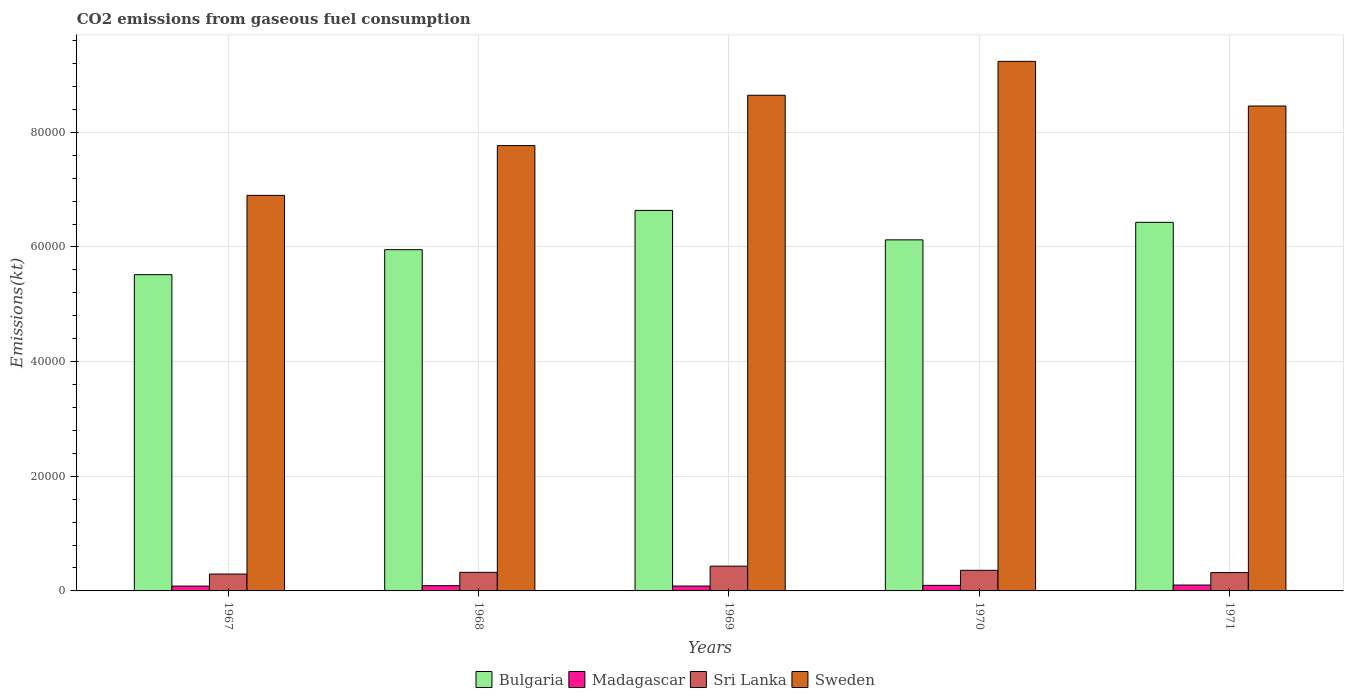How many groups of bars are there?
Provide a succinct answer. 5. Are the number of bars per tick equal to the number of legend labels?
Make the answer very short. Yes. Are the number of bars on each tick of the X-axis equal?
Keep it short and to the point. Yes. How many bars are there on the 1st tick from the right?
Keep it short and to the point. 4. What is the label of the 1st group of bars from the left?
Ensure brevity in your answer.  1967. What is the amount of CO2 emitted in Sri Lanka in 1968?
Offer a very short reply. 3241.63. Across all years, what is the maximum amount of CO2 emitted in Bulgaria?
Give a very brief answer. 6.64e+04. Across all years, what is the minimum amount of CO2 emitted in Bulgaria?
Keep it short and to the point. 5.52e+04. In which year was the amount of CO2 emitted in Sri Lanka minimum?
Provide a short and direct response. 1967. What is the total amount of CO2 emitted in Sri Lanka in the graph?
Provide a short and direct response. 1.73e+04. What is the difference between the amount of CO2 emitted in Sweden in 1967 and that in 1968?
Your answer should be compact. -8683.46. What is the difference between the amount of CO2 emitted in Sweden in 1969 and the amount of CO2 emitted in Madagascar in 1970?
Your answer should be compact. 8.55e+04. What is the average amount of CO2 emitted in Sweden per year?
Offer a very short reply. 8.20e+04. In the year 1971, what is the difference between the amount of CO2 emitted in Madagascar and amount of CO2 emitted in Sweden?
Ensure brevity in your answer.  -8.36e+04. In how many years, is the amount of CO2 emitted in Madagascar greater than 68000 kt?
Keep it short and to the point. 0. What is the ratio of the amount of CO2 emitted in Bulgaria in 1967 to that in 1968?
Make the answer very short. 0.93. Is the amount of CO2 emitted in Bulgaria in 1967 less than that in 1970?
Give a very brief answer. Yes. Is the difference between the amount of CO2 emitted in Madagascar in 1969 and 1971 greater than the difference between the amount of CO2 emitted in Sweden in 1969 and 1971?
Your answer should be very brief. No. What is the difference between the highest and the second highest amount of CO2 emitted in Madagascar?
Give a very brief answer. 55. What is the difference between the highest and the lowest amount of CO2 emitted in Sri Lanka?
Ensure brevity in your answer.  1371.46. In how many years, is the amount of CO2 emitted in Sri Lanka greater than the average amount of CO2 emitted in Sri Lanka taken over all years?
Give a very brief answer. 2. Is the sum of the amount of CO2 emitted in Bulgaria in 1969 and 1970 greater than the maximum amount of CO2 emitted in Sweden across all years?
Provide a succinct answer. Yes. What does the 1st bar from the left in 1968 represents?
Your answer should be very brief. Bulgaria. What does the 2nd bar from the right in 1969 represents?
Offer a very short reply. Sri Lanka. Is it the case that in every year, the sum of the amount of CO2 emitted in Sweden and amount of CO2 emitted in Bulgaria is greater than the amount of CO2 emitted in Madagascar?
Provide a succinct answer. Yes. How many bars are there?
Offer a terse response. 20. Are all the bars in the graph horizontal?
Keep it short and to the point. No. What is the difference between two consecutive major ticks on the Y-axis?
Offer a very short reply. 2.00e+04. Does the graph contain any zero values?
Your response must be concise. No. Does the graph contain grids?
Make the answer very short. Yes. Where does the legend appear in the graph?
Your answer should be compact. Bottom center. What is the title of the graph?
Your answer should be compact. CO2 emissions from gaseous fuel consumption. Does "Denmark" appear as one of the legend labels in the graph?
Offer a very short reply. No. What is the label or title of the Y-axis?
Provide a short and direct response. Emissions(kt). What is the Emissions(kt) in Bulgaria in 1967?
Offer a very short reply. 5.52e+04. What is the Emissions(kt) in Madagascar in 1967?
Ensure brevity in your answer.  843.41. What is the Emissions(kt) in Sri Lanka in 1967?
Offer a very short reply. 2948.27. What is the Emissions(kt) of Sweden in 1967?
Offer a terse response. 6.90e+04. What is the Emissions(kt) in Bulgaria in 1968?
Ensure brevity in your answer.  5.95e+04. What is the Emissions(kt) in Madagascar in 1968?
Your answer should be compact. 913.08. What is the Emissions(kt) in Sri Lanka in 1968?
Offer a terse response. 3241.63. What is the Emissions(kt) in Sweden in 1968?
Provide a short and direct response. 7.77e+04. What is the Emissions(kt) of Bulgaria in 1969?
Your answer should be very brief. 6.64e+04. What is the Emissions(kt) in Madagascar in 1969?
Offer a terse response. 850.74. What is the Emissions(kt) of Sri Lanka in 1969?
Offer a very short reply. 4319.73. What is the Emissions(kt) of Sweden in 1969?
Offer a terse response. 8.65e+04. What is the Emissions(kt) in Bulgaria in 1970?
Offer a very short reply. 6.12e+04. What is the Emissions(kt) in Madagascar in 1970?
Your response must be concise. 971.75. What is the Emissions(kt) of Sri Lanka in 1970?
Your response must be concise. 3597.33. What is the Emissions(kt) of Sweden in 1970?
Offer a terse response. 9.24e+04. What is the Emissions(kt) in Bulgaria in 1971?
Give a very brief answer. 6.43e+04. What is the Emissions(kt) in Madagascar in 1971?
Provide a succinct answer. 1026.76. What is the Emissions(kt) of Sri Lanka in 1971?
Offer a terse response. 3197.62. What is the Emissions(kt) of Sweden in 1971?
Offer a terse response. 8.46e+04. Across all years, what is the maximum Emissions(kt) of Bulgaria?
Provide a short and direct response. 6.64e+04. Across all years, what is the maximum Emissions(kt) of Madagascar?
Your answer should be very brief. 1026.76. Across all years, what is the maximum Emissions(kt) in Sri Lanka?
Offer a terse response. 4319.73. Across all years, what is the maximum Emissions(kt) in Sweden?
Offer a terse response. 9.24e+04. Across all years, what is the minimum Emissions(kt) of Bulgaria?
Your answer should be compact. 5.52e+04. Across all years, what is the minimum Emissions(kt) in Madagascar?
Ensure brevity in your answer.  843.41. Across all years, what is the minimum Emissions(kt) in Sri Lanka?
Ensure brevity in your answer.  2948.27. Across all years, what is the minimum Emissions(kt) of Sweden?
Your response must be concise. 6.90e+04. What is the total Emissions(kt) in Bulgaria in the graph?
Give a very brief answer. 3.07e+05. What is the total Emissions(kt) in Madagascar in the graph?
Provide a short and direct response. 4605.75. What is the total Emissions(kt) in Sri Lanka in the graph?
Provide a succinct answer. 1.73e+04. What is the total Emissions(kt) of Sweden in the graph?
Offer a very short reply. 4.10e+05. What is the difference between the Emissions(kt) in Bulgaria in 1967 and that in 1968?
Offer a terse response. -4360.06. What is the difference between the Emissions(kt) of Madagascar in 1967 and that in 1968?
Make the answer very short. -69.67. What is the difference between the Emissions(kt) of Sri Lanka in 1967 and that in 1968?
Keep it short and to the point. -293.36. What is the difference between the Emissions(kt) in Sweden in 1967 and that in 1968?
Your response must be concise. -8683.46. What is the difference between the Emissions(kt) of Bulgaria in 1967 and that in 1969?
Make the answer very short. -1.12e+04. What is the difference between the Emissions(kt) in Madagascar in 1967 and that in 1969?
Provide a succinct answer. -7.33. What is the difference between the Emissions(kt) of Sri Lanka in 1967 and that in 1969?
Provide a short and direct response. -1371.46. What is the difference between the Emissions(kt) of Sweden in 1967 and that in 1969?
Give a very brief answer. -1.75e+04. What is the difference between the Emissions(kt) of Bulgaria in 1967 and that in 1970?
Offer a terse response. -6072.55. What is the difference between the Emissions(kt) in Madagascar in 1967 and that in 1970?
Make the answer very short. -128.34. What is the difference between the Emissions(kt) of Sri Lanka in 1967 and that in 1970?
Give a very brief answer. -649.06. What is the difference between the Emissions(kt) in Sweden in 1967 and that in 1970?
Provide a succinct answer. -2.34e+04. What is the difference between the Emissions(kt) of Bulgaria in 1967 and that in 1971?
Ensure brevity in your answer.  -9134.5. What is the difference between the Emissions(kt) of Madagascar in 1967 and that in 1971?
Provide a short and direct response. -183.35. What is the difference between the Emissions(kt) in Sri Lanka in 1967 and that in 1971?
Ensure brevity in your answer.  -249.36. What is the difference between the Emissions(kt) of Sweden in 1967 and that in 1971?
Provide a short and direct response. -1.56e+04. What is the difference between the Emissions(kt) in Bulgaria in 1968 and that in 1969?
Provide a short and direct response. -6849.96. What is the difference between the Emissions(kt) in Madagascar in 1968 and that in 1969?
Offer a very short reply. 62.34. What is the difference between the Emissions(kt) of Sri Lanka in 1968 and that in 1969?
Provide a short and direct response. -1078.1. What is the difference between the Emissions(kt) in Sweden in 1968 and that in 1969?
Ensure brevity in your answer.  -8782.47. What is the difference between the Emissions(kt) in Bulgaria in 1968 and that in 1970?
Your answer should be very brief. -1712.49. What is the difference between the Emissions(kt) in Madagascar in 1968 and that in 1970?
Make the answer very short. -58.67. What is the difference between the Emissions(kt) of Sri Lanka in 1968 and that in 1970?
Offer a terse response. -355.7. What is the difference between the Emissions(kt) of Sweden in 1968 and that in 1970?
Offer a terse response. -1.47e+04. What is the difference between the Emissions(kt) of Bulgaria in 1968 and that in 1971?
Ensure brevity in your answer.  -4774.43. What is the difference between the Emissions(kt) of Madagascar in 1968 and that in 1971?
Keep it short and to the point. -113.68. What is the difference between the Emissions(kt) in Sri Lanka in 1968 and that in 1971?
Keep it short and to the point. 44. What is the difference between the Emissions(kt) in Sweden in 1968 and that in 1971?
Give a very brief answer. -6904.96. What is the difference between the Emissions(kt) of Bulgaria in 1969 and that in 1970?
Ensure brevity in your answer.  5137.47. What is the difference between the Emissions(kt) of Madagascar in 1969 and that in 1970?
Provide a short and direct response. -121.01. What is the difference between the Emissions(kt) in Sri Lanka in 1969 and that in 1970?
Your answer should be very brief. 722.4. What is the difference between the Emissions(kt) in Sweden in 1969 and that in 1970?
Make the answer very short. -5911.2. What is the difference between the Emissions(kt) in Bulgaria in 1969 and that in 1971?
Your response must be concise. 2075.52. What is the difference between the Emissions(kt) in Madagascar in 1969 and that in 1971?
Ensure brevity in your answer.  -176.02. What is the difference between the Emissions(kt) in Sri Lanka in 1969 and that in 1971?
Your answer should be compact. 1122.1. What is the difference between the Emissions(kt) in Sweden in 1969 and that in 1971?
Your answer should be compact. 1877.5. What is the difference between the Emissions(kt) in Bulgaria in 1970 and that in 1971?
Your answer should be compact. -3061.95. What is the difference between the Emissions(kt) in Madagascar in 1970 and that in 1971?
Keep it short and to the point. -55.01. What is the difference between the Emissions(kt) of Sri Lanka in 1970 and that in 1971?
Provide a succinct answer. 399.7. What is the difference between the Emissions(kt) in Sweden in 1970 and that in 1971?
Ensure brevity in your answer.  7788.71. What is the difference between the Emissions(kt) of Bulgaria in 1967 and the Emissions(kt) of Madagascar in 1968?
Make the answer very short. 5.43e+04. What is the difference between the Emissions(kt) of Bulgaria in 1967 and the Emissions(kt) of Sri Lanka in 1968?
Your answer should be compact. 5.19e+04. What is the difference between the Emissions(kt) in Bulgaria in 1967 and the Emissions(kt) in Sweden in 1968?
Your answer should be compact. -2.25e+04. What is the difference between the Emissions(kt) of Madagascar in 1967 and the Emissions(kt) of Sri Lanka in 1968?
Your answer should be very brief. -2398.22. What is the difference between the Emissions(kt) in Madagascar in 1967 and the Emissions(kt) in Sweden in 1968?
Provide a succinct answer. -7.68e+04. What is the difference between the Emissions(kt) in Sri Lanka in 1967 and the Emissions(kt) in Sweden in 1968?
Your answer should be very brief. -7.47e+04. What is the difference between the Emissions(kt) of Bulgaria in 1967 and the Emissions(kt) of Madagascar in 1969?
Your response must be concise. 5.43e+04. What is the difference between the Emissions(kt) in Bulgaria in 1967 and the Emissions(kt) in Sri Lanka in 1969?
Give a very brief answer. 5.08e+04. What is the difference between the Emissions(kt) of Bulgaria in 1967 and the Emissions(kt) of Sweden in 1969?
Offer a very short reply. -3.13e+04. What is the difference between the Emissions(kt) in Madagascar in 1967 and the Emissions(kt) in Sri Lanka in 1969?
Make the answer very short. -3476.32. What is the difference between the Emissions(kt) in Madagascar in 1967 and the Emissions(kt) in Sweden in 1969?
Your answer should be very brief. -8.56e+04. What is the difference between the Emissions(kt) in Sri Lanka in 1967 and the Emissions(kt) in Sweden in 1969?
Make the answer very short. -8.35e+04. What is the difference between the Emissions(kt) of Bulgaria in 1967 and the Emissions(kt) of Madagascar in 1970?
Offer a very short reply. 5.42e+04. What is the difference between the Emissions(kt) in Bulgaria in 1967 and the Emissions(kt) in Sri Lanka in 1970?
Your answer should be very brief. 5.16e+04. What is the difference between the Emissions(kt) in Bulgaria in 1967 and the Emissions(kt) in Sweden in 1970?
Ensure brevity in your answer.  -3.72e+04. What is the difference between the Emissions(kt) in Madagascar in 1967 and the Emissions(kt) in Sri Lanka in 1970?
Your response must be concise. -2753.92. What is the difference between the Emissions(kt) in Madagascar in 1967 and the Emissions(kt) in Sweden in 1970?
Ensure brevity in your answer.  -9.15e+04. What is the difference between the Emissions(kt) of Sri Lanka in 1967 and the Emissions(kt) of Sweden in 1970?
Make the answer very short. -8.94e+04. What is the difference between the Emissions(kt) in Bulgaria in 1967 and the Emissions(kt) in Madagascar in 1971?
Your response must be concise. 5.41e+04. What is the difference between the Emissions(kt) of Bulgaria in 1967 and the Emissions(kt) of Sri Lanka in 1971?
Provide a succinct answer. 5.20e+04. What is the difference between the Emissions(kt) of Bulgaria in 1967 and the Emissions(kt) of Sweden in 1971?
Give a very brief answer. -2.94e+04. What is the difference between the Emissions(kt) in Madagascar in 1967 and the Emissions(kt) in Sri Lanka in 1971?
Provide a succinct answer. -2354.21. What is the difference between the Emissions(kt) of Madagascar in 1967 and the Emissions(kt) of Sweden in 1971?
Your answer should be very brief. -8.37e+04. What is the difference between the Emissions(kt) of Sri Lanka in 1967 and the Emissions(kt) of Sweden in 1971?
Keep it short and to the point. -8.16e+04. What is the difference between the Emissions(kt) in Bulgaria in 1968 and the Emissions(kt) in Madagascar in 1969?
Provide a short and direct response. 5.87e+04. What is the difference between the Emissions(kt) in Bulgaria in 1968 and the Emissions(kt) in Sri Lanka in 1969?
Offer a very short reply. 5.52e+04. What is the difference between the Emissions(kt) in Bulgaria in 1968 and the Emissions(kt) in Sweden in 1969?
Offer a very short reply. -2.69e+04. What is the difference between the Emissions(kt) in Madagascar in 1968 and the Emissions(kt) in Sri Lanka in 1969?
Offer a very short reply. -3406.64. What is the difference between the Emissions(kt) in Madagascar in 1968 and the Emissions(kt) in Sweden in 1969?
Keep it short and to the point. -8.56e+04. What is the difference between the Emissions(kt) of Sri Lanka in 1968 and the Emissions(kt) of Sweden in 1969?
Give a very brief answer. -8.32e+04. What is the difference between the Emissions(kt) in Bulgaria in 1968 and the Emissions(kt) in Madagascar in 1970?
Offer a terse response. 5.86e+04. What is the difference between the Emissions(kt) in Bulgaria in 1968 and the Emissions(kt) in Sri Lanka in 1970?
Provide a short and direct response. 5.59e+04. What is the difference between the Emissions(kt) of Bulgaria in 1968 and the Emissions(kt) of Sweden in 1970?
Your answer should be very brief. -3.29e+04. What is the difference between the Emissions(kt) in Madagascar in 1968 and the Emissions(kt) in Sri Lanka in 1970?
Provide a short and direct response. -2684.24. What is the difference between the Emissions(kt) in Madagascar in 1968 and the Emissions(kt) in Sweden in 1970?
Ensure brevity in your answer.  -9.15e+04. What is the difference between the Emissions(kt) in Sri Lanka in 1968 and the Emissions(kt) in Sweden in 1970?
Keep it short and to the point. -8.91e+04. What is the difference between the Emissions(kt) in Bulgaria in 1968 and the Emissions(kt) in Madagascar in 1971?
Your response must be concise. 5.85e+04. What is the difference between the Emissions(kt) of Bulgaria in 1968 and the Emissions(kt) of Sri Lanka in 1971?
Ensure brevity in your answer.  5.63e+04. What is the difference between the Emissions(kt) of Bulgaria in 1968 and the Emissions(kt) of Sweden in 1971?
Make the answer very short. -2.51e+04. What is the difference between the Emissions(kt) of Madagascar in 1968 and the Emissions(kt) of Sri Lanka in 1971?
Your response must be concise. -2284.54. What is the difference between the Emissions(kt) in Madagascar in 1968 and the Emissions(kt) in Sweden in 1971?
Provide a succinct answer. -8.37e+04. What is the difference between the Emissions(kt) in Sri Lanka in 1968 and the Emissions(kt) in Sweden in 1971?
Your answer should be compact. -8.13e+04. What is the difference between the Emissions(kt) in Bulgaria in 1969 and the Emissions(kt) in Madagascar in 1970?
Provide a short and direct response. 6.54e+04. What is the difference between the Emissions(kt) of Bulgaria in 1969 and the Emissions(kt) of Sri Lanka in 1970?
Offer a very short reply. 6.28e+04. What is the difference between the Emissions(kt) of Bulgaria in 1969 and the Emissions(kt) of Sweden in 1970?
Keep it short and to the point. -2.60e+04. What is the difference between the Emissions(kt) in Madagascar in 1969 and the Emissions(kt) in Sri Lanka in 1970?
Your response must be concise. -2746.58. What is the difference between the Emissions(kt) of Madagascar in 1969 and the Emissions(kt) of Sweden in 1970?
Offer a terse response. -9.15e+04. What is the difference between the Emissions(kt) of Sri Lanka in 1969 and the Emissions(kt) of Sweden in 1970?
Your response must be concise. -8.81e+04. What is the difference between the Emissions(kt) in Bulgaria in 1969 and the Emissions(kt) in Madagascar in 1971?
Offer a very short reply. 6.53e+04. What is the difference between the Emissions(kt) in Bulgaria in 1969 and the Emissions(kt) in Sri Lanka in 1971?
Provide a short and direct response. 6.32e+04. What is the difference between the Emissions(kt) of Bulgaria in 1969 and the Emissions(kt) of Sweden in 1971?
Provide a succinct answer. -1.82e+04. What is the difference between the Emissions(kt) in Madagascar in 1969 and the Emissions(kt) in Sri Lanka in 1971?
Offer a very short reply. -2346.88. What is the difference between the Emissions(kt) of Madagascar in 1969 and the Emissions(kt) of Sweden in 1971?
Keep it short and to the point. -8.37e+04. What is the difference between the Emissions(kt) in Sri Lanka in 1969 and the Emissions(kt) in Sweden in 1971?
Ensure brevity in your answer.  -8.03e+04. What is the difference between the Emissions(kt) of Bulgaria in 1970 and the Emissions(kt) of Madagascar in 1971?
Provide a succinct answer. 6.02e+04. What is the difference between the Emissions(kt) of Bulgaria in 1970 and the Emissions(kt) of Sri Lanka in 1971?
Keep it short and to the point. 5.80e+04. What is the difference between the Emissions(kt) in Bulgaria in 1970 and the Emissions(kt) in Sweden in 1971?
Give a very brief answer. -2.34e+04. What is the difference between the Emissions(kt) of Madagascar in 1970 and the Emissions(kt) of Sri Lanka in 1971?
Provide a short and direct response. -2225.87. What is the difference between the Emissions(kt) of Madagascar in 1970 and the Emissions(kt) of Sweden in 1971?
Provide a succinct answer. -8.36e+04. What is the difference between the Emissions(kt) of Sri Lanka in 1970 and the Emissions(kt) of Sweden in 1971?
Give a very brief answer. -8.10e+04. What is the average Emissions(kt) in Bulgaria per year?
Ensure brevity in your answer.  6.13e+04. What is the average Emissions(kt) in Madagascar per year?
Your answer should be compact. 921.15. What is the average Emissions(kt) of Sri Lanka per year?
Offer a very short reply. 3460.91. What is the average Emissions(kt) in Sweden per year?
Provide a short and direct response. 8.20e+04. In the year 1967, what is the difference between the Emissions(kt) of Bulgaria and Emissions(kt) of Madagascar?
Keep it short and to the point. 5.43e+04. In the year 1967, what is the difference between the Emissions(kt) in Bulgaria and Emissions(kt) in Sri Lanka?
Give a very brief answer. 5.22e+04. In the year 1967, what is the difference between the Emissions(kt) of Bulgaria and Emissions(kt) of Sweden?
Provide a short and direct response. -1.38e+04. In the year 1967, what is the difference between the Emissions(kt) of Madagascar and Emissions(kt) of Sri Lanka?
Ensure brevity in your answer.  -2104.86. In the year 1967, what is the difference between the Emissions(kt) of Madagascar and Emissions(kt) of Sweden?
Give a very brief answer. -6.82e+04. In the year 1967, what is the difference between the Emissions(kt) in Sri Lanka and Emissions(kt) in Sweden?
Give a very brief answer. -6.61e+04. In the year 1968, what is the difference between the Emissions(kt) of Bulgaria and Emissions(kt) of Madagascar?
Offer a terse response. 5.86e+04. In the year 1968, what is the difference between the Emissions(kt) in Bulgaria and Emissions(kt) in Sri Lanka?
Offer a very short reply. 5.63e+04. In the year 1968, what is the difference between the Emissions(kt) of Bulgaria and Emissions(kt) of Sweden?
Your response must be concise. -1.82e+04. In the year 1968, what is the difference between the Emissions(kt) in Madagascar and Emissions(kt) in Sri Lanka?
Make the answer very short. -2328.55. In the year 1968, what is the difference between the Emissions(kt) of Madagascar and Emissions(kt) of Sweden?
Offer a terse response. -7.68e+04. In the year 1968, what is the difference between the Emissions(kt) of Sri Lanka and Emissions(kt) of Sweden?
Ensure brevity in your answer.  -7.44e+04. In the year 1969, what is the difference between the Emissions(kt) of Bulgaria and Emissions(kt) of Madagascar?
Your answer should be very brief. 6.55e+04. In the year 1969, what is the difference between the Emissions(kt) in Bulgaria and Emissions(kt) in Sri Lanka?
Give a very brief answer. 6.21e+04. In the year 1969, what is the difference between the Emissions(kt) of Bulgaria and Emissions(kt) of Sweden?
Your answer should be compact. -2.01e+04. In the year 1969, what is the difference between the Emissions(kt) in Madagascar and Emissions(kt) in Sri Lanka?
Your answer should be very brief. -3468.98. In the year 1969, what is the difference between the Emissions(kt) of Madagascar and Emissions(kt) of Sweden?
Provide a short and direct response. -8.56e+04. In the year 1969, what is the difference between the Emissions(kt) of Sri Lanka and Emissions(kt) of Sweden?
Your answer should be very brief. -8.21e+04. In the year 1970, what is the difference between the Emissions(kt) in Bulgaria and Emissions(kt) in Madagascar?
Your answer should be compact. 6.03e+04. In the year 1970, what is the difference between the Emissions(kt) in Bulgaria and Emissions(kt) in Sri Lanka?
Your answer should be very brief. 5.76e+04. In the year 1970, what is the difference between the Emissions(kt) of Bulgaria and Emissions(kt) of Sweden?
Your answer should be compact. -3.11e+04. In the year 1970, what is the difference between the Emissions(kt) in Madagascar and Emissions(kt) in Sri Lanka?
Offer a very short reply. -2625.57. In the year 1970, what is the difference between the Emissions(kt) in Madagascar and Emissions(kt) in Sweden?
Your answer should be compact. -9.14e+04. In the year 1970, what is the difference between the Emissions(kt) of Sri Lanka and Emissions(kt) of Sweden?
Offer a very short reply. -8.88e+04. In the year 1971, what is the difference between the Emissions(kt) in Bulgaria and Emissions(kt) in Madagascar?
Give a very brief answer. 6.33e+04. In the year 1971, what is the difference between the Emissions(kt) in Bulgaria and Emissions(kt) in Sri Lanka?
Keep it short and to the point. 6.11e+04. In the year 1971, what is the difference between the Emissions(kt) of Bulgaria and Emissions(kt) of Sweden?
Ensure brevity in your answer.  -2.03e+04. In the year 1971, what is the difference between the Emissions(kt) in Madagascar and Emissions(kt) in Sri Lanka?
Keep it short and to the point. -2170.86. In the year 1971, what is the difference between the Emissions(kt) in Madagascar and Emissions(kt) in Sweden?
Provide a short and direct response. -8.36e+04. In the year 1971, what is the difference between the Emissions(kt) of Sri Lanka and Emissions(kt) of Sweden?
Ensure brevity in your answer.  -8.14e+04. What is the ratio of the Emissions(kt) of Bulgaria in 1967 to that in 1968?
Provide a succinct answer. 0.93. What is the ratio of the Emissions(kt) of Madagascar in 1967 to that in 1968?
Your answer should be very brief. 0.92. What is the ratio of the Emissions(kt) in Sri Lanka in 1967 to that in 1968?
Ensure brevity in your answer.  0.91. What is the ratio of the Emissions(kt) in Sweden in 1967 to that in 1968?
Ensure brevity in your answer.  0.89. What is the ratio of the Emissions(kt) of Bulgaria in 1967 to that in 1969?
Provide a short and direct response. 0.83. What is the ratio of the Emissions(kt) in Sri Lanka in 1967 to that in 1969?
Your response must be concise. 0.68. What is the ratio of the Emissions(kt) of Sweden in 1967 to that in 1969?
Your response must be concise. 0.8. What is the ratio of the Emissions(kt) of Bulgaria in 1967 to that in 1970?
Give a very brief answer. 0.9. What is the ratio of the Emissions(kt) in Madagascar in 1967 to that in 1970?
Provide a short and direct response. 0.87. What is the ratio of the Emissions(kt) of Sri Lanka in 1967 to that in 1970?
Give a very brief answer. 0.82. What is the ratio of the Emissions(kt) of Sweden in 1967 to that in 1970?
Make the answer very short. 0.75. What is the ratio of the Emissions(kt) in Bulgaria in 1967 to that in 1971?
Keep it short and to the point. 0.86. What is the ratio of the Emissions(kt) in Madagascar in 1967 to that in 1971?
Your answer should be very brief. 0.82. What is the ratio of the Emissions(kt) in Sri Lanka in 1967 to that in 1971?
Offer a very short reply. 0.92. What is the ratio of the Emissions(kt) of Sweden in 1967 to that in 1971?
Give a very brief answer. 0.82. What is the ratio of the Emissions(kt) in Bulgaria in 1968 to that in 1969?
Offer a terse response. 0.9. What is the ratio of the Emissions(kt) in Madagascar in 1968 to that in 1969?
Your answer should be very brief. 1.07. What is the ratio of the Emissions(kt) of Sri Lanka in 1968 to that in 1969?
Ensure brevity in your answer.  0.75. What is the ratio of the Emissions(kt) in Sweden in 1968 to that in 1969?
Provide a succinct answer. 0.9. What is the ratio of the Emissions(kt) in Bulgaria in 1968 to that in 1970?
Provide a succinct answer. 0.97. What is the ratio of the Emissions(kt) in Madagascar in 1968 to that in 1970?
Provide a succinct answer. 0.94. What is the ratio of the Emissions(kt) of Sri Lanka in 1968 to that in 1970?
Give a very brief answer. 0.9. What is the ratio of the Emissions(kt) of Sweden in 1968 to that in 1970?
Provide a short and direct response. 0.84. What is the ratio of the Emissions(kt) in Bulgaria in 1968 to that in 1971?
Ensure brevity in your answer.  0.93. What is the ratio of the Emissions(kt) of Madagascar in 1968 to that in 1971?
Offer a very short reply. 0.89. What is the ratio of the Emissions(kt) of Sri Lanka in 1968 to that in 1971?
Your answer should be very brief. 1.01. What is the ratio of the Emissions(kt) of Sweden in 1968 to that in 1971?
Your response must be concise. 0.92. What is the ratio of the Emissions(kt) in Bulgaria in 1969 to that in 1970?
Keep it short and to the point. 1.08. What is the ratio of the Emissions(kt) of Madagascar in 1969 to that in 1970?
Offer a terse response. 0.88. What is the ratio of the Emissions(kt) in Sri Lanka in 1969 to that in 1970?
Offer a terse response. 1.2. What is the ratio of the Emissions(kt) of Sweden in 1969 to that in 1970?
Your response must be concise. 0.94. What is the ratio of the Emissions(kt) of Bulgaria in 1969 to that in 1971?
Provide a succinct answer. 1.03. What is the ratio of the Emissions(kt) in Madagascar in 1969 to that in 1971?
Provide a short and direct response. 0.83. What is the ratio of the Emissions(kt) in Sri Lanka in 1969 to that in 1971?
Provide a succinct answer. 1.35. What is the ratio of the Emissions(kt) in Sweden in 1969 to that in 1971?
Keep it short and to the point. 1.02. What is the ratio of the Emissions(kt) in Bulgaria in 1970 to that in 1971?
Ensure brevity in your answer.  0.95. What is the ratio of the Emissions(kt) of Madagascar in 1970 to that in 1971?
Give a very brief answer. 0.95. What is the ratio of the Emissions(kt) of Sweden in 1970 to that in 1971?
Provide a succinct answer. 1.09. What is the difference between the highest and the second highest Emissions(kt) of Bulgaria?
Ensure brevity in your answer.  2075.52. What is the difference between the highest and the second highest Emissions(kt) in Madagascar?
Give a very brief answer. 55.01. What is the difference between the highest and the second highest Emissions(kt) of Sri Lanka?
Give a very brief answer. 722.4. What is the difference between the highest and the second highest Emissions(kt) in Sweden?
Provide a short and direct response. 5911.2. What is the difference between the highest and the lowest Emissions(kt) in Bulgaria?
Make the answer very short. 1.12e+04. What is the difference between the highest and the lowest Emissions(kt) in Madagascar?
Ensure brevity in your answer.  183.35. What is the difference between the highest and the lowest Emissions(kt) in Sri Lanka?
Your response must be concise. 1371.46. What is the difference between the highest and the lowest Emissions(kt) of Sweden?
Offer a terse response. 2.34e+04. 